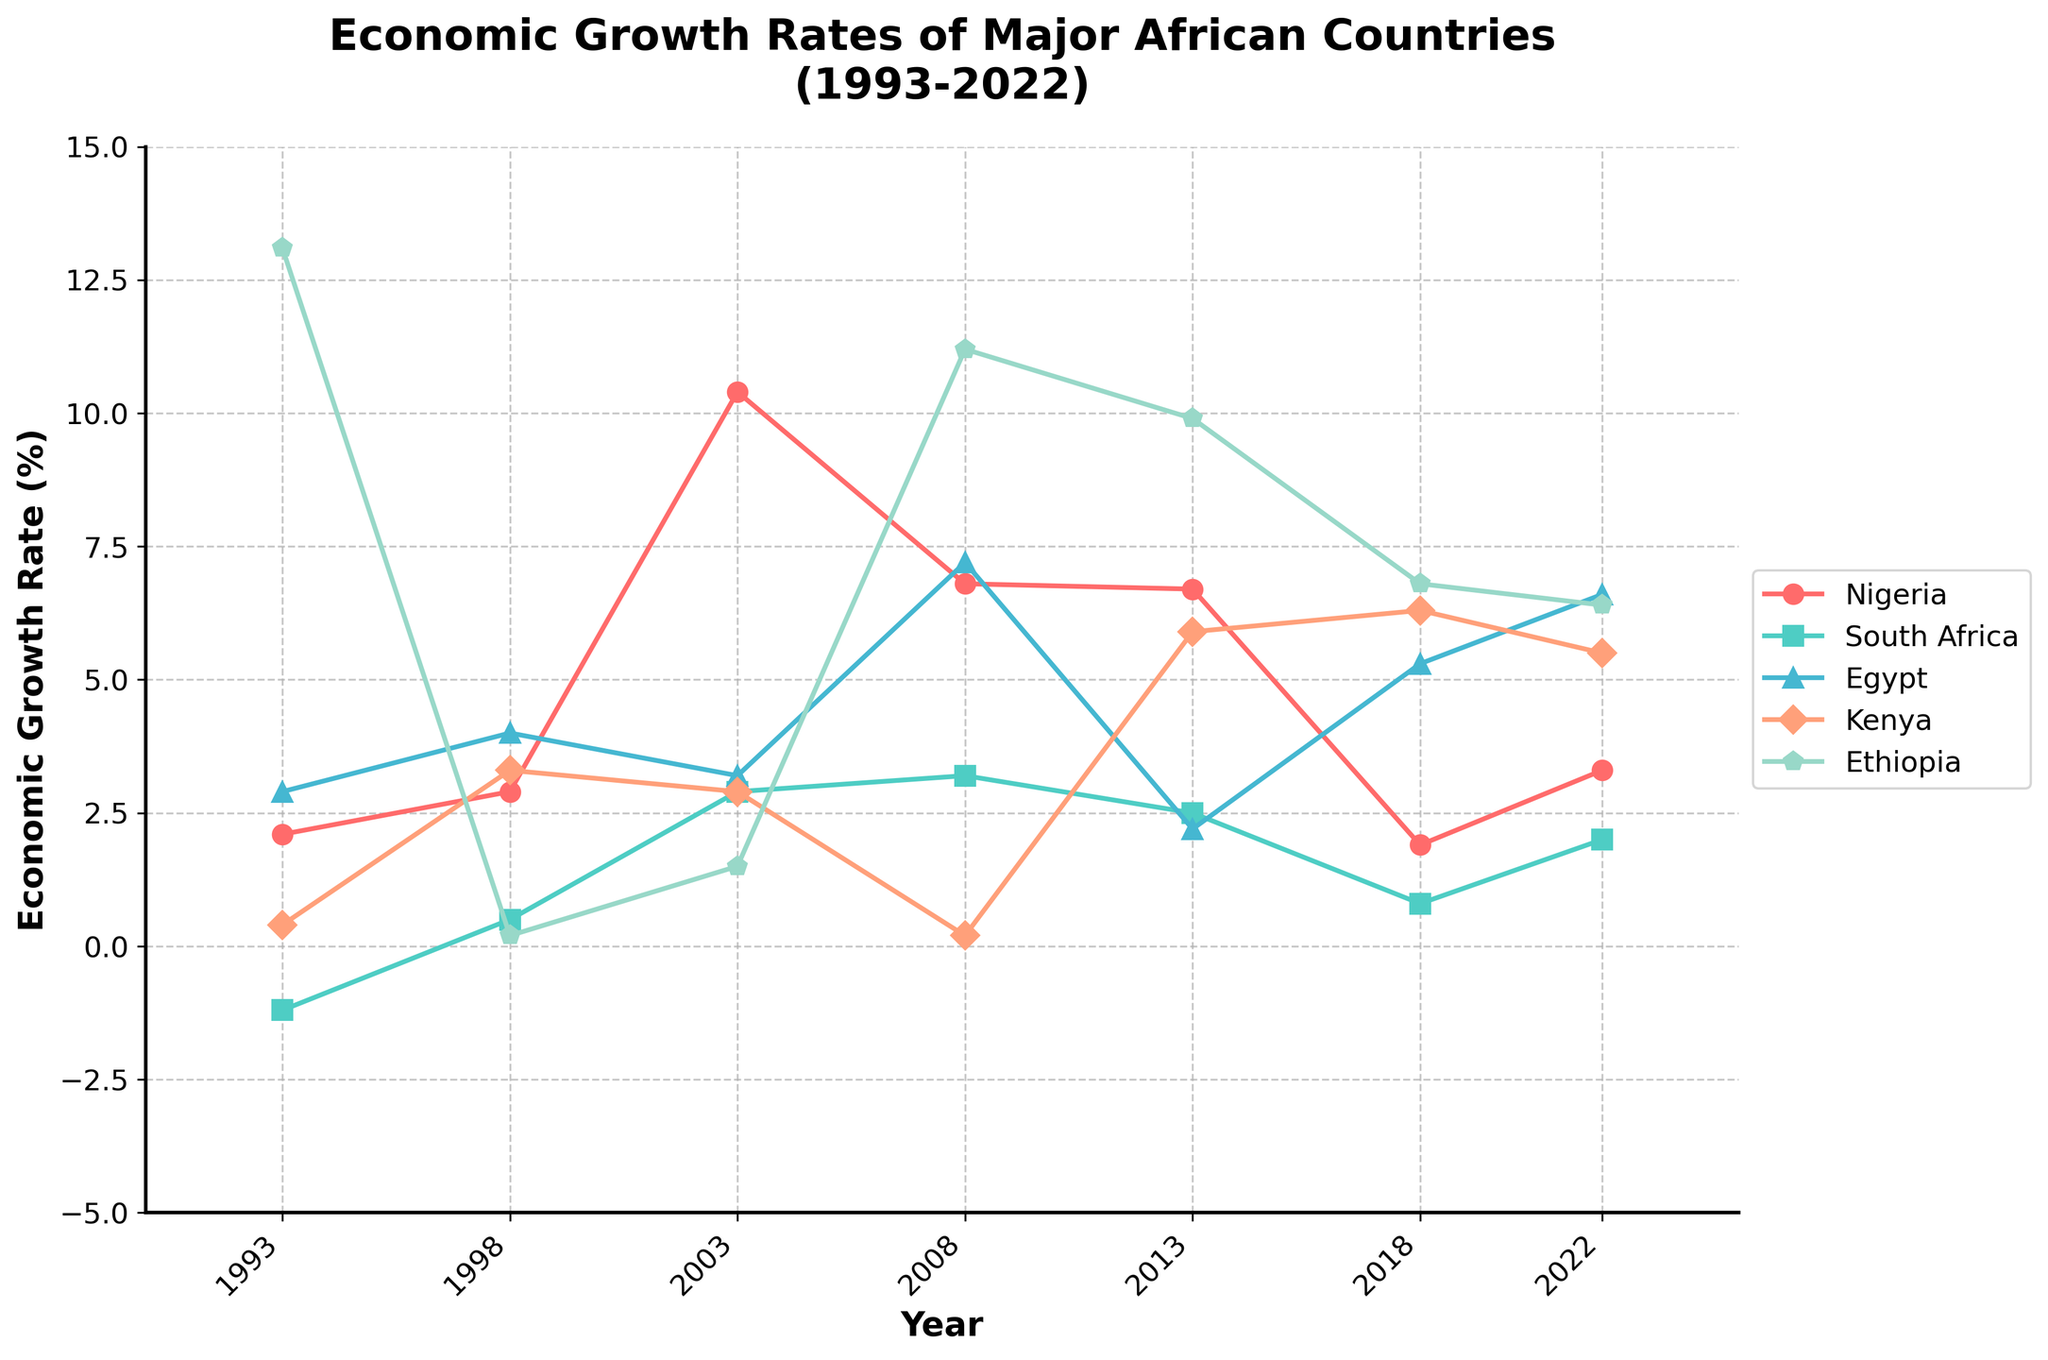Which country had the highest economic growth rate in 1993? To find the highest economic growth rate in 1993, look at the values listed for each country in that year. The highest value is 13.1, which belongs to Ethiopia.
Answer: Ethiopia What was the economic growth rate difference between Nigeria and South Africa in 2003? Check the growth rates for Nigeria (10.4) and South Africa (2.9) in 2003. Calculate the difference: 10.4 - 2.9 = 7.5.
Answer: 7.5 Which countries had negative economic growth rates at any point between 1993 and 2022? Observe each country’s growth rates over the years. South Africa in 1993 had a negative growth rate (-1.2). No other countries had negative rates.
Answer: South Africa In which year did Ethiopia experience its lowest economic growth rate? Look at the values for Ethiopia across all the years. The lowest growth rate for Ethiopia is 0.2 in 1998.
Answer: 1998 Compare the economic growth rates of Kenya and Egypt in 2018. Which country had a higher growth rate? Evaluate the growth rates for Kenya (6.3) and Egypt (5.3) in 2018. Kenya’s rate is higher.
Answer: Kenya What is the average economic growth rate of Nigeria from 2013 to 2022? Check the values for Nigeria in 2013 (6.7), 2018 (1.9), and 2022 (3.3). Calculate the average: (6.7 + 1.9 + 3.3) / 3 = 11.9 / 3 ≈ 4.0.
Answer: 4.0 Did South Africa ever have an economic growth rate greater than 3% between 1993 and 2022? Review South Africa’s growth rates over the years. The only year where it was greater than 3% is 2003 (3.2).
Answer: Yes What was the overall trend of Egypt's economic growth rate from 1998 to 2022? Trace the pattern for Egypt's growth rates from 1998 (4.0) to 2022 (6.6). The trend shows general fluctuation with a slight overall increase.
Answer: Increasing Considering 2022, rank the countries by their economic growth rate from highest to lowest. Check the 2022 growth rates: Ethiopia (6.4), Egypt (6.6), Kenya (5.5), Nigeria (3.3), South Africa (2.0). Rank them as: Egypt, Ethiopia, Kenya, Nigeria, South Africa.
Answer: Egypt, Ethiopia, Kenya, Nigeria, South Africa Which country had a consistent increase in the economic growth rate in the period 2013 to 2022? Examine the rates from 2013 to 2022. Ethiopia showed a consistent increase from 9.9 (2013) to 6.8 (2018) to 6.4 (2022).
Answer: Ethiopia 